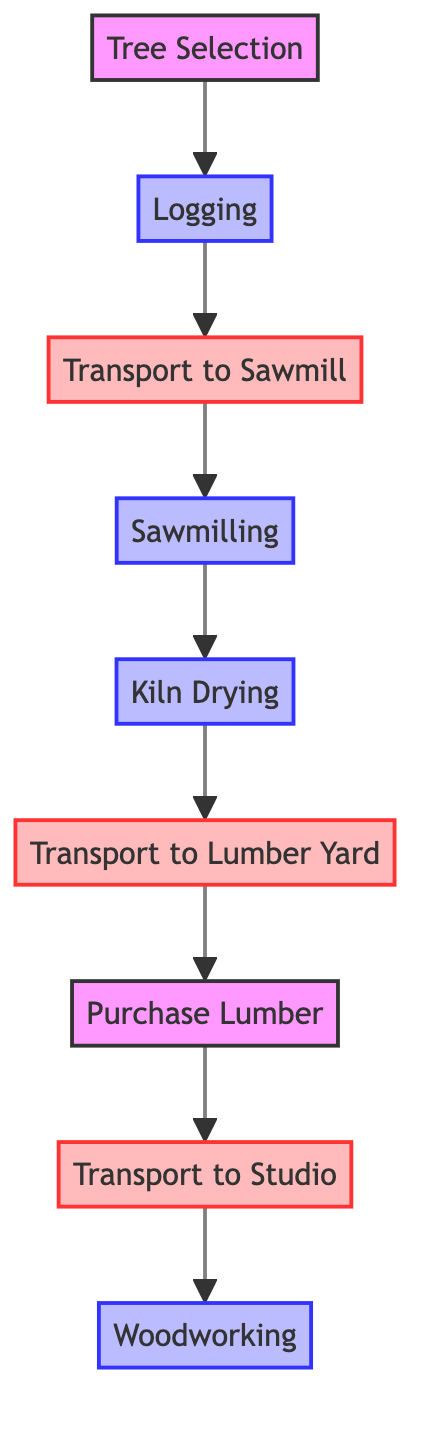What is the first step in the wood procurement process? The first step is "Tree Selection," which involves identifying and selecting mature trees suitable for logging before any further processes can begin.
Answer: Tree Selection How many total nodes are present in the diagram? By counting all the distinct elements listed in the data, there are a total of 9 nodes: Tree Selection, Logging, Transport to Sawmill, Sawmilling, Kiln Drying, Transport to Lumber Yard, Purchase Lumber, Transport to Studio, and Woodworking.
Answer: 9 What comes after "Transport to Sawmill"? The diagram shows that "Transport to Sawmill" leads directly to the next step "Sawmilling," indicating this is the following action taken after transport.
Answer: Sawmilling Which process occurs after "Kiln Drying"? Following "Kiln Drying" as indicated in the diagram is "Transport to Lumber Yard." This means once the lumber is dried, it is transported to a lumber yard next.
Answer: Transport to Lumber Yard What type of node is "Woodworking"? In the diagram, "Woodworking" is classified as a process node since it involves various woodworking tasks to create artworks and studio furnishings as indicated by its description.
Answer: Process What is the final step in the wood procurement process? The last node in the sequential flow is "Woodworking," meaning it is the final stage where actual works of art and studio furnishings are created using the procured lumber.
Answer: Woodworking How many transport steps are there in the process? Based on the diagram, there are 3 transport steps: "Transport to Sawmill," "Transport to Lumber Yard," and "Transport to Studio," making the total three stages that involve transportation.
Answer: 3 Is "Sawmilling" a transport step? "Sawmilling" is not classified as a transport step; it is a process where logs are processed into lumber, differentiating it from transport nodes in the graph.
Answer: No What is the relationship between "Purchase Lumber" and "Transport to Studio"? The relationship indicates that "Purchase Lumber" directly leads to "Transport to Studio," showing that after purchasing, the next action is delivering the lumber to the studio.
Answer: Directly leads to 